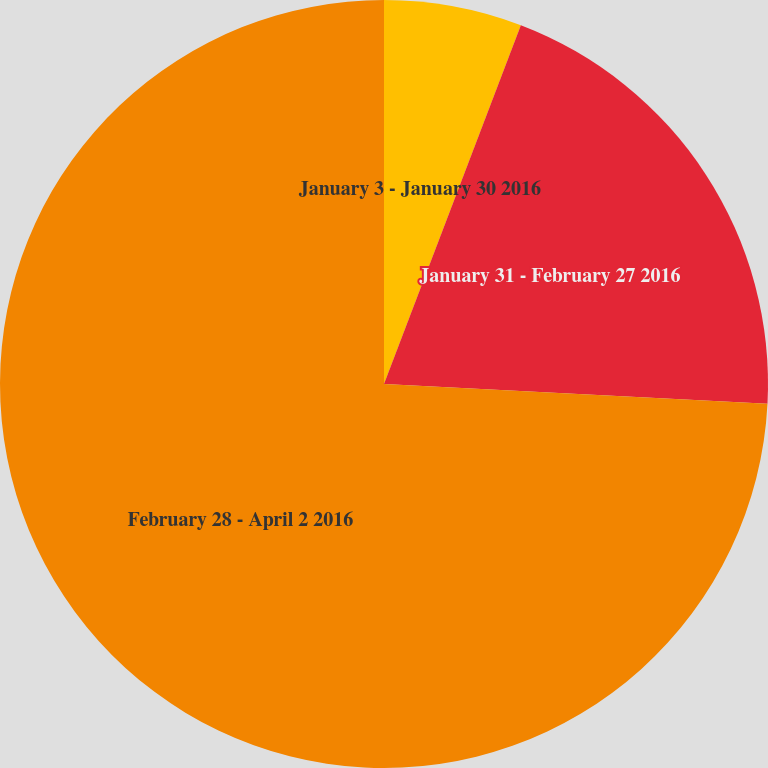Convert chart. <chart><loc_0><loc_0><loc_500><loc_500><pie_chart><fcel>January 3 - January 30 2016<fcel>January 31 - February 27 2016<fcel>February 28 - April 2 2016<nl><fcel>5.8%<fcel>20.02%<fcel>74.18%<nl></chart> 